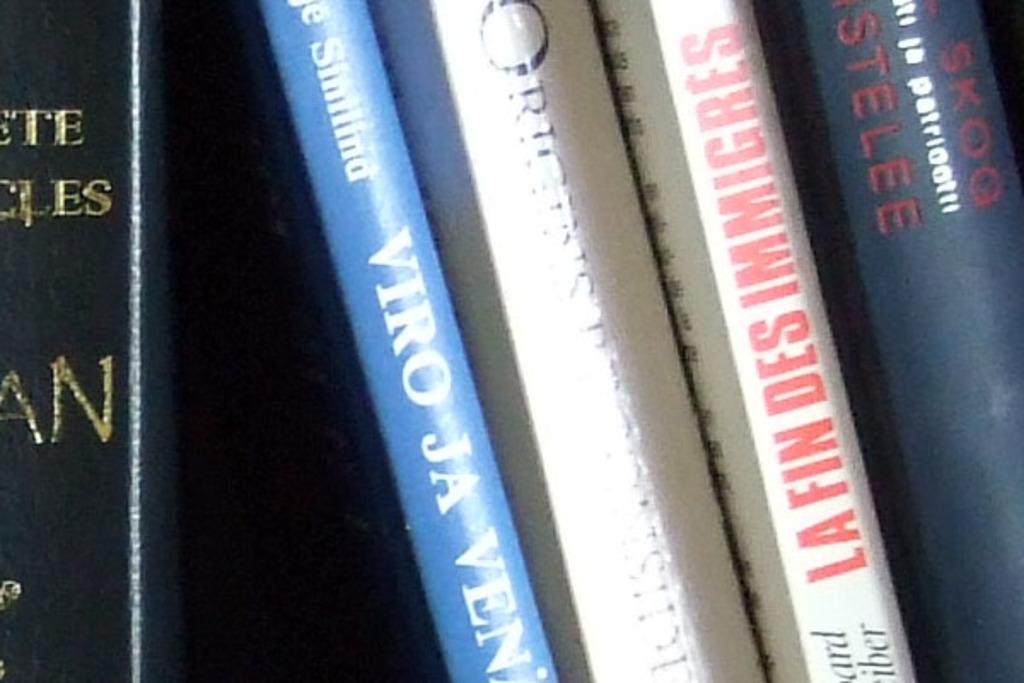What is the title of the white book with red writing?
Ensure brevity in your answer.  La fin des immigres. What is the title of the blue book and white letters?
Make the answer very short. Viro ja ven. 